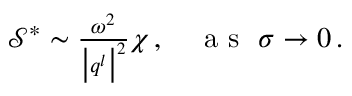Convert formula to latex. <formula><loc_0><loc_0><loc_500><loc_500>\begin{array} { r } { \mathcal { S } ^ { * } \sim \frac { \omega ^ { 2 } } { \left | q ^ { l } \right | ^ { 2 } } \chi \, , a s \sigma \rightarrow 0 \, . } \end{array}</formula> 